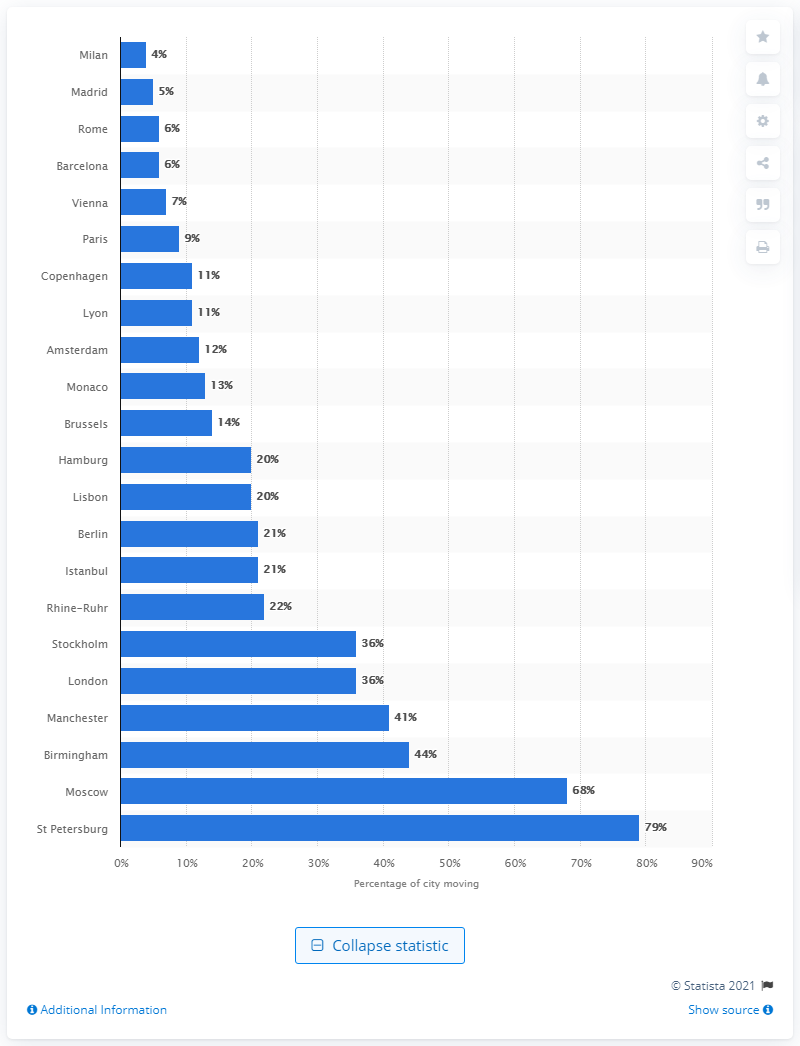Mention a couple of crucial points in this snapshot. According to data from the week ending March 22, a city had 36% of its population still moving, and that city was London. 